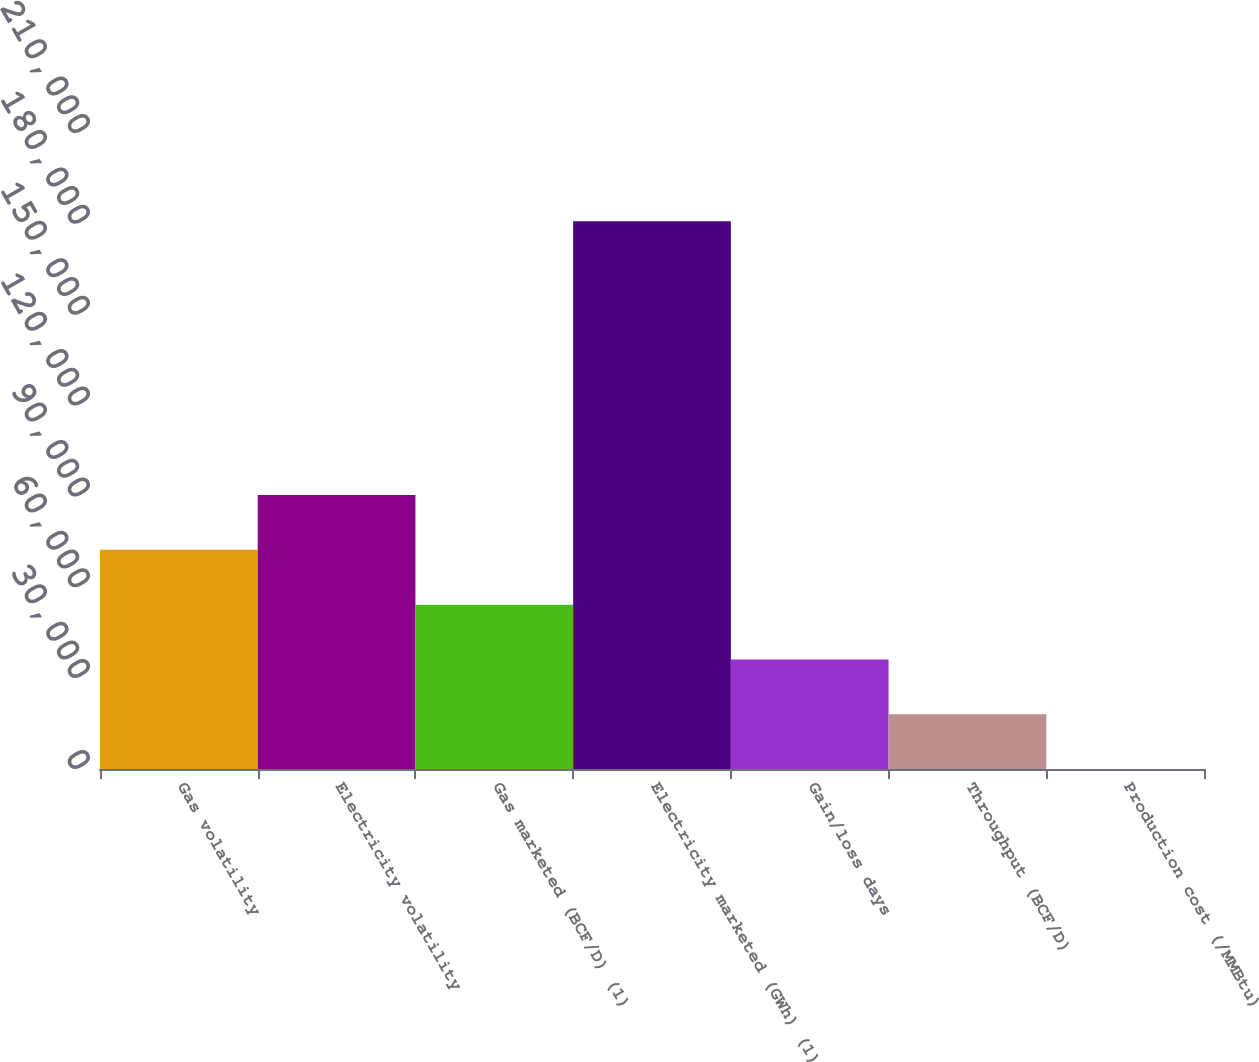Convert chart. <chart><loc_0><loc_0><loc_500><loc_500><bar_chart><fcel>Gas volatility<fcel>Electricity volatility<fcel>Gas marketed (BCF/D) (1)<fcel>Electricity marketed (GWh) (1)<fcel>Gain/loss days<fcel>Throughput (BCF/D)<fcel>Production cost (/MMBtu)<nl><fcel>72357.2<fcel>90446.5<fcel>54268<fcel>180893<fcel>36178.7<fcel>18089.4<fcel>0.09<nl></chart> 